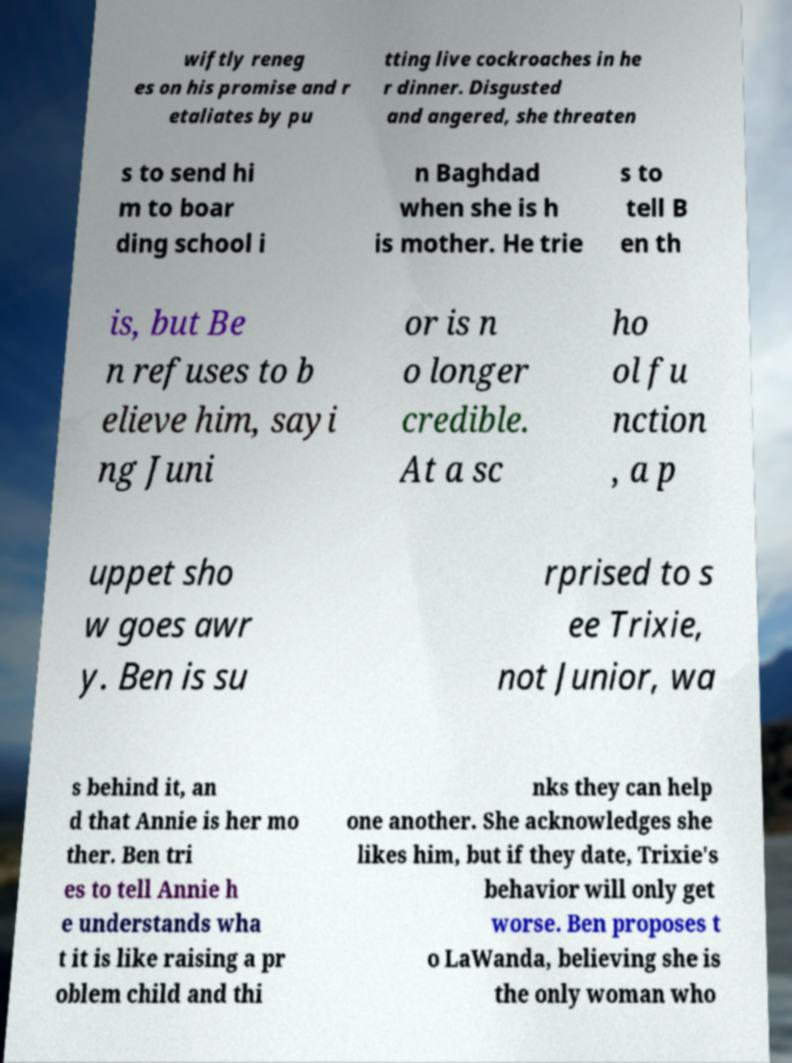Could you assist in decoding the text presented in this image and type it out clearly? wiftly reneg es on his promise and r etaliates by pu tting live cockroaches in he r dinner. Disgusted and angered, she threaten s to send hi m to boar ding school i n Baghdad when she is h is mother. He trie s to tell B en th is, but Be n refuses to b elieve him, sayi ng Juni or is n o longer credible. At a sc ho ol fu nction , a p uppet sho w goes awr y. Ben is su rprised to s ee Trixie, not Junior, wa s behind it, an d that Annie is her mo ther. Ben tri es to tell Annie h e understands wha t it is like raising a pr oblem child and thi nks they can help one another. She acknowledges she likes him, but if they date, Trixie's behavior will only get worse. Ben proposes t o LaWanda, believing she is the only woman who 